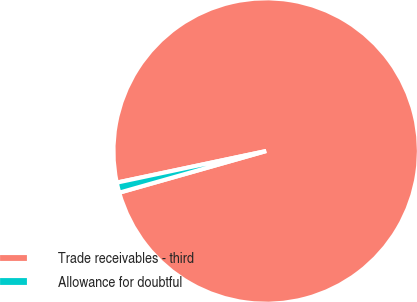<chart> <loc_0><loc_0><loc_500><loc_500><pie_chart><fcel>Trade receivables - third<fcel>Allowance for doubtful<nl><fcel>98.92%<fcel>1.08%<nl></chart> 